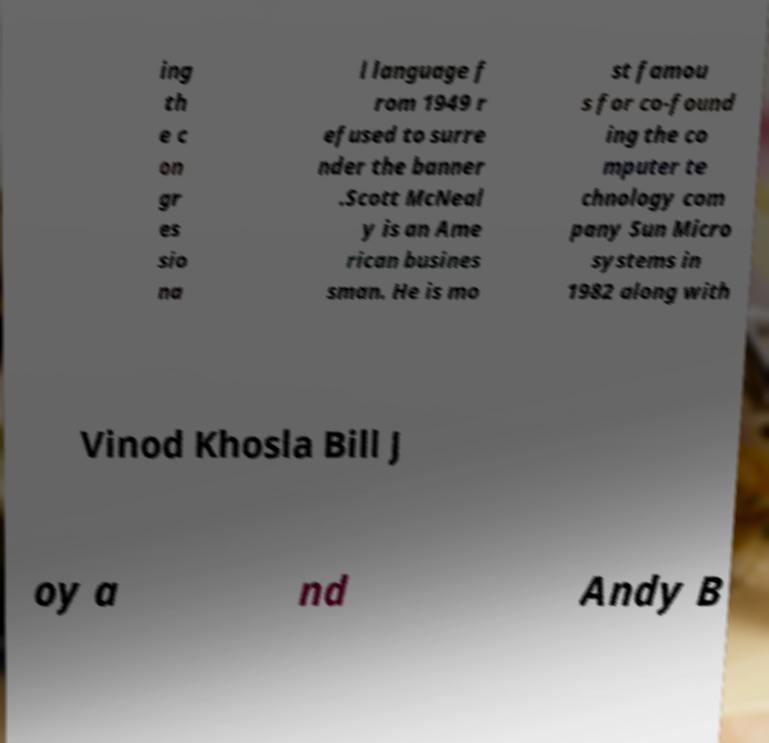Can you accurately transcribe the text from the provided image for me? ing th e c on gr es sio na l language f rom 1949 r efused to surre nder the banner .Scott McNeal y is an Ame rican busines sman. He is mo st famou s for co-found ing the co mputer te chnology com pany Sun Micro systems in 1982 along with Vinod Khosla Bill J oy a nd Andy B 